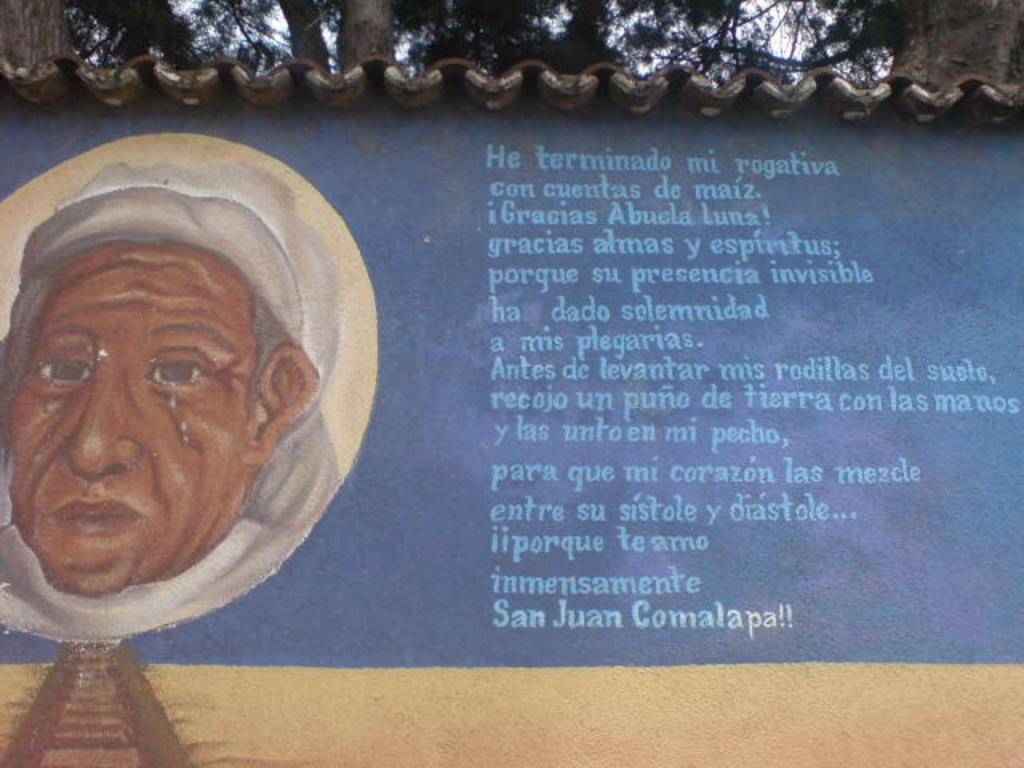Could you give a brief overview of what you see in this image? In this picture there is a building and there is a picture of a person on the wall and there is text on the wall and there are roof tiles on the top of the building. Behind the building there are trees. At the top there is sky. 